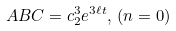Convert formula to latex. <formula><loc_0><loc_0><loc_500><loc_500>A B C = c _ { 2 } ^ { 3 } e ^ { 3 \ell t } , \, ( n = 0 )</formula> 